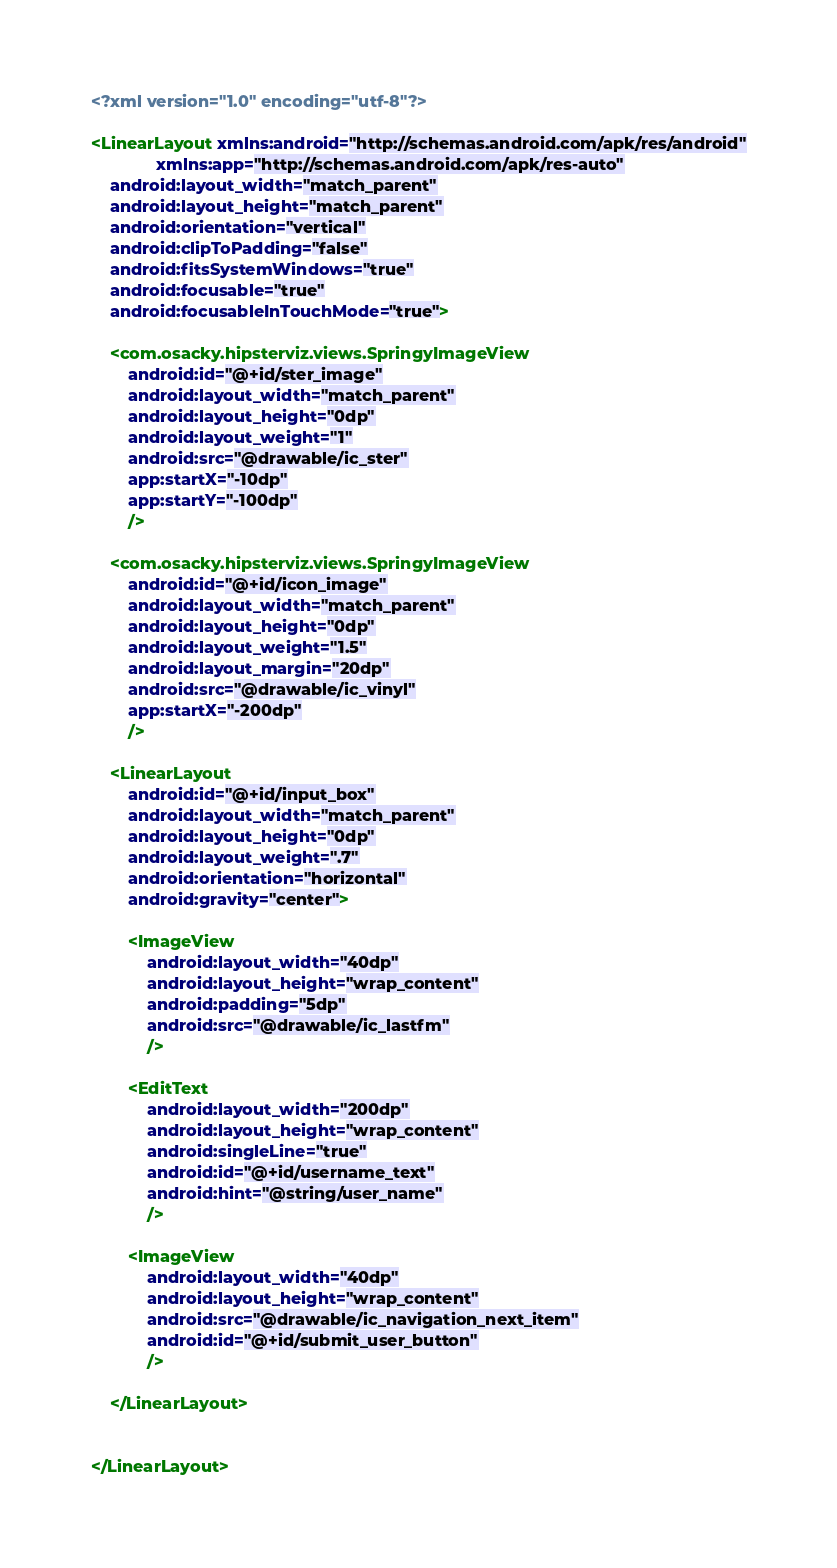<code> <loc_0><loc_0><loc_500><loc_500><_XML_><?xml version="1.0" encoding="utf-8"?>

<LinearLayout xmlns:android="http://schemas.android.com/apk/res/android"
              xmlns:app="http://schemas.android.com/apk/res-auto"
    android:layout_width="match_parent"
    android:layout_height="match_parent"
    android:orientation="vertical"
    android:clipToPadding="false"
    android:fitsSystemWindows="true"
    android:focusable="true"
    android:focusableInTouchMode="true">

    <com.osacky.hipsterviz.views.SpringyImageView
        android:id="@+id/ster_image"
        android:layout_width="match_parent"
        android:layout_height="0dp"
        android:layout_weight="1"
        android:src="@drawable/ic_ster"
        app:startX="-10dp"
        app:startY="-100dp"
        />

    <com.osacky.hipsterviz.views.SpringyImageView
        android:id="@+id/icon_image"
        android:layout_width="match_parent"
        android:layout_height="0dp"
        android:layout_weight="1.5"
        android:layout_margin="20dp"
        android:src="@drawable/ic_vinyl"
        app:startX="-200dp"
        />

    <LinearLayout
        android:id="@+id/input_box"
        android:layout_width="match_parent"
        android:layout_height="0dp"
        android:layout_weight=".7"
        android:orientation="horizontal"
        android:gravity="center">

        <ImageView
            android:layout_width="40dp"
            android:layout_height="wrap_content"
            android:padding="5dp"
            android:src="@drawable/ic_lastfm"
            />

        <EditText
            android:layout_width="200dp"
            android:layout_height="wrap_content"
            android:singleLine="true"
            android:id="@+id/username_text"
            android:hint="@string/user_name"
            />

        <ImageView
            android:layout_width="40dp"
            android:layout_height="wrap_content"
            android:src="@drawable/ic_navigation_next_item"
            android:id="@+id/submit_user_button"
            />

    </LinearLayout>


</LinearLayout></code> 